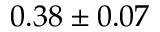<formula> <loc_0><loc_0><loc_500><loc_500>0 . 3 8 \pm 0 . 0 7</formula> 